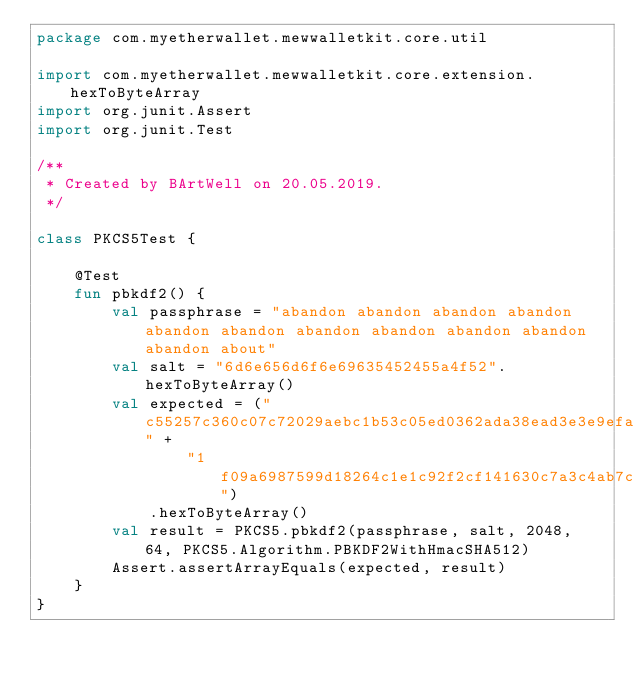Convert code to text. <code><loc_0><loc_0><loc_500><loc_500><_Kotlin_>package com.myetherwallet.mewwalletkit.core.util

import com.myetherwallet.mewwalletkit.core.extension.hexToByteArray
import org.junit.Assert
import org.junit.Test

/**
 * Created by BArtWell on 20.05.2019.
 */

class PKCS5Test {

    @Test
    fun pbkdf2() {
        val passphrase = "abandon abandon abandon abandon abandon abandon abandon abandon abandon abandon abandon about"
        val salt = "6d6e656d6f6e69635452455a4f52".hexToByteArray()
        val expected = ("c55257c360c07c72029aebc1b53c05ed0362ada38ead3e3e9efa3708e5349553" +
                "1f09a6987599d18264c1e1c92f2cf141630c7a3c4ab7c81b2f001698e7463b04")
            .hexToByteArray()
        val result = PKCS5.pbkdf2(passphrase, salt, 2048, 64, PKCS5.Algorithm.PBKDF2WithHmacSHA512)
        Assert.assertArrayEquals(expected, result)
    }
}</code> 